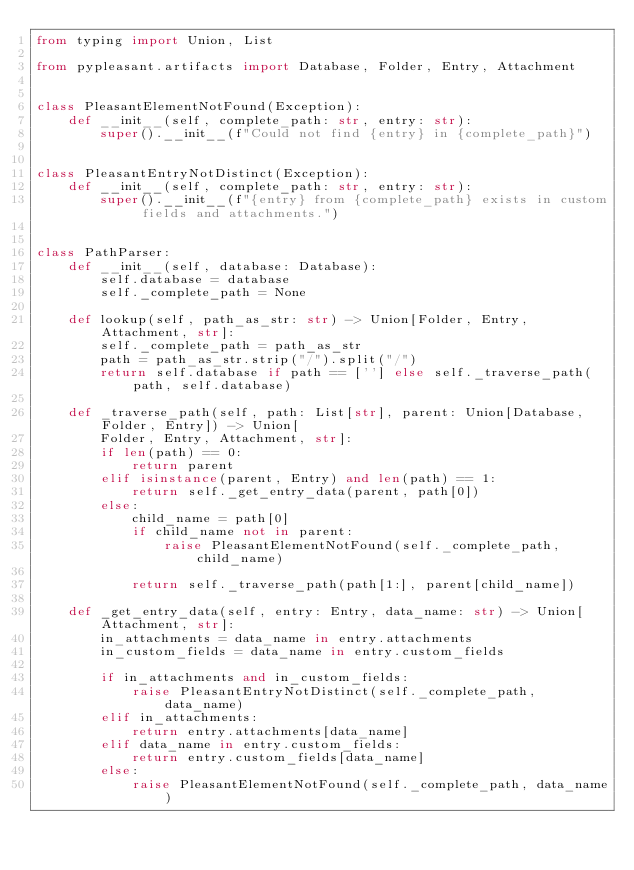Convert code to text. <code><loc_0><loc_0><loc_500><loc_500><_Python_>from typing import Union, List

from pypleasant.artifacts import Database, Folder, Entry, Attachment


class PleasantElementNotFound(Exception):
    def __init__(self, complete_path: str, entry: str):
        super().__init__(f"Could not find {entry} in {complete_path}")


class PleasantEntryNotDistinct(Exception):
    def __init__(self, complete_path: str, entry: str):
        super().__init__(f"{entry} from {complete_path} exists in custom fields and attachments.")


class PathParser:
    def __init__(self, database: Database):
        self.database = database
        self._complete_path = None

    def lookup(self, path_as_str: str) -> Union[Folder, Entry, Attachment, str]:
        self._complete_path = path_as_str
        path = path_as_str.strip("/").split("/")
        return self.database if path == [''] else self._traverse_path(path, self.database)

    def _traverse_path(self, path: List[str], parent: Union[Database, Folder, Entry]) -> Union[
        Folder, Entry, Attachment, str]:
        if len(path) == 0:
            return parent
        elif isinstance(parent, Entry) and len(path) == 1:
            return self._get_entry_data(parent, path[0])
        else:
            child_name = path[0]
            if child_name not in parent:
                raise PleasantElementNotFound(self._complete_path, child_name)

            return self._traverse_path(path[1:], parent[child_name])

    def _get_entry_data(self, entry: Entry, data_name: str) -> Union[Attachment, str]:
        in_attachments = data_name in entry.attachments
        in_custom_fields = data_name in entry.custom_fields

        if in_attachments and in_custom_fields:
            raise PleasantEntryNotDistinct(self._complete_path, data_name)
        elif in_attachments:
            return entry.attachments[data_name]
        elif data_name in entry.custom_fields:
            return entry.custom_fields[data_name]
        else:
            raise PleasantElementNotFound(self._complete_path, data_name)
</code> 